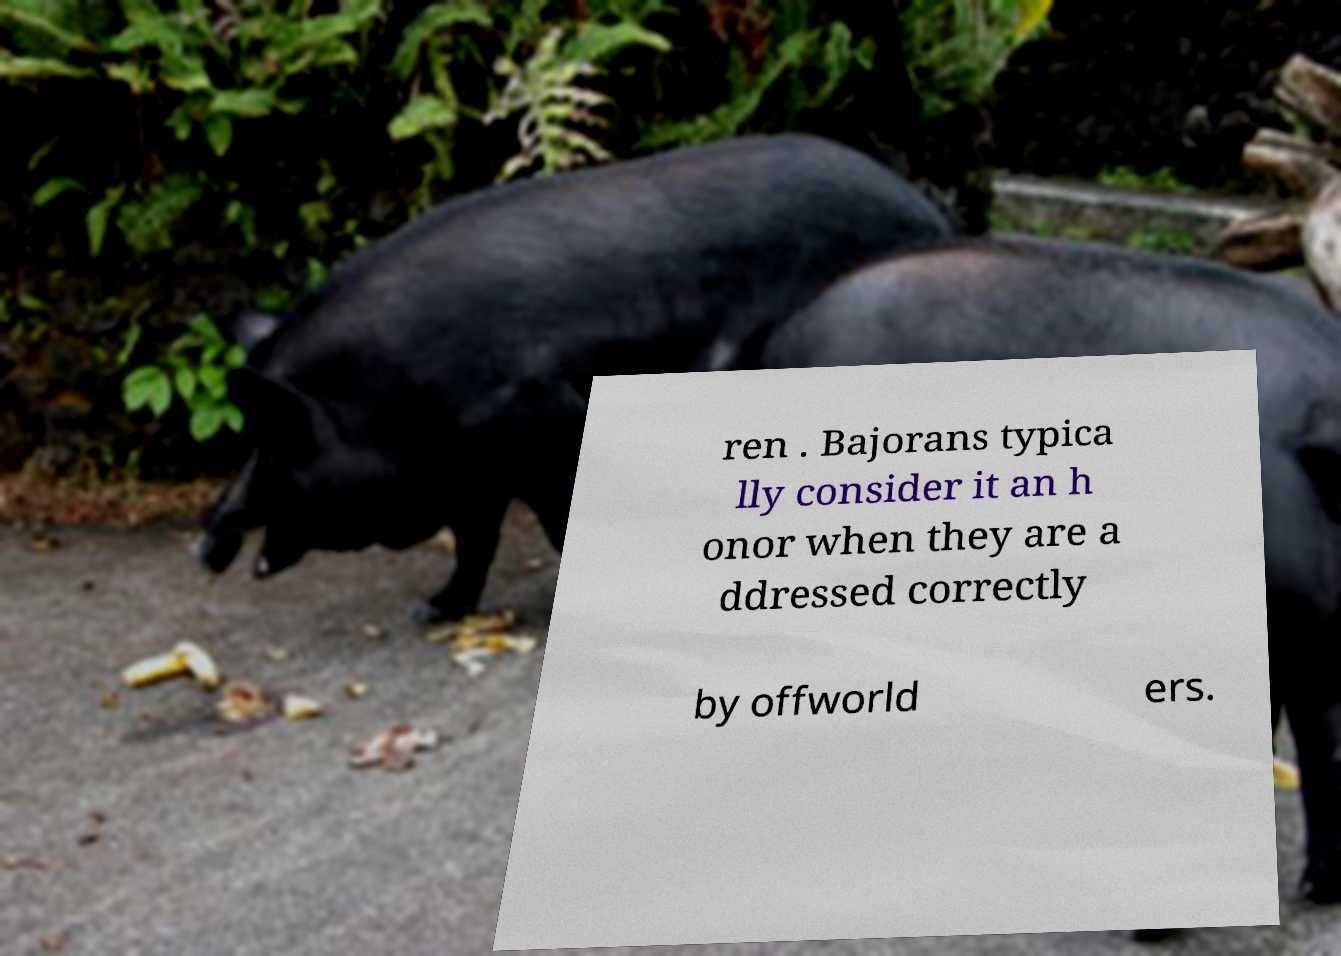There's text embedded in this image that I need extracted. Can you transcribe it verbatim? ren . Bajorans typica lly consider it an h onor when they are a ddressed correctly by offworld ers. 